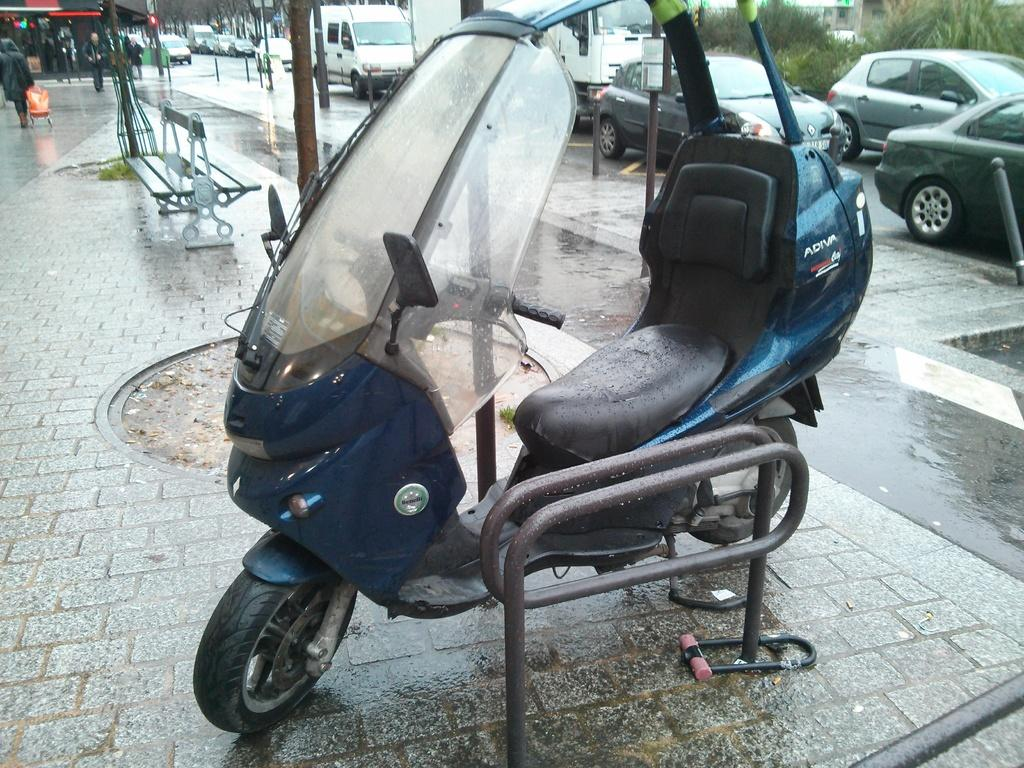What type of vehicle is in the image? There is a scooter in the image. What else can be seen on the road in the image? There are vehicles on the road in the image. What type of seating is available in the image? There is a bench in the image. Who is present in the image? There is a group of people standing in the image. What type of vegetation is in the image? There are trees in the image. What type of brass instrument is being played by the group of people in the image? There is no brass instrument or any indication of music being played in the image. What type of noise can be heard coming from the scooter in the image? The image is static, so no noise can be heard from the scooter or any other subject in the image. 